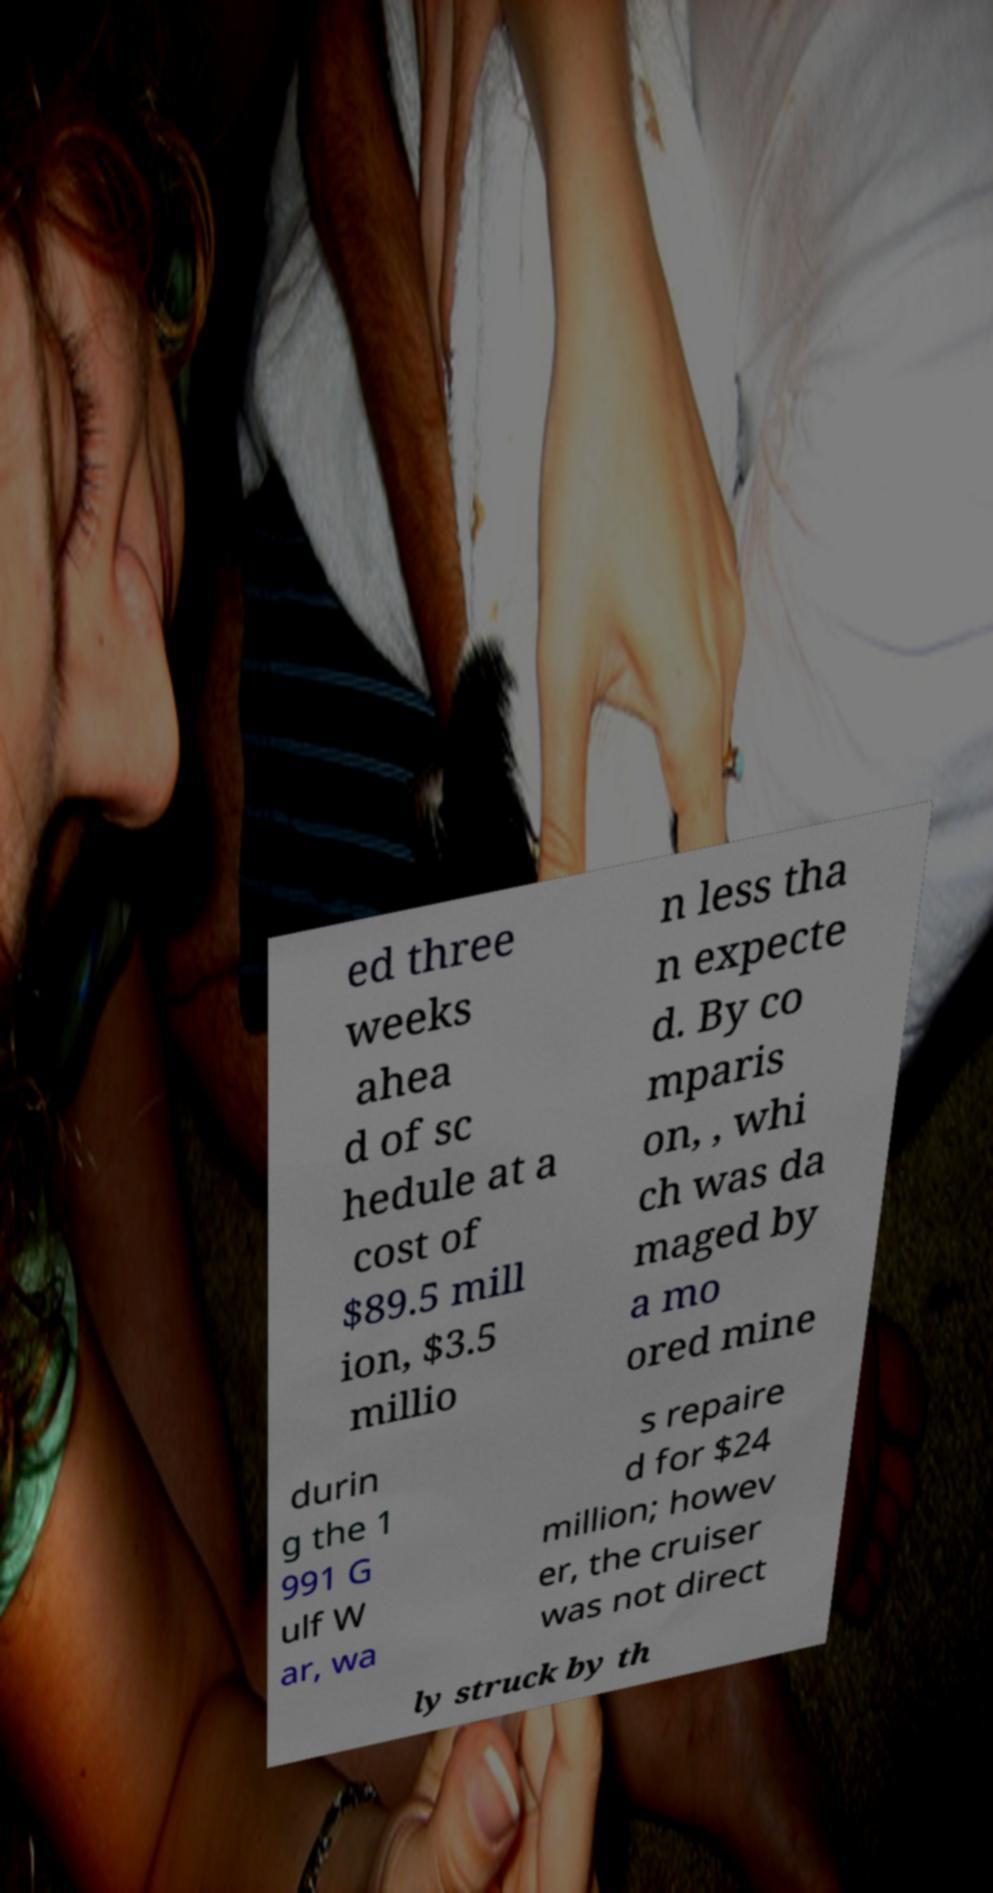Please read and relay the text visible in this image. What does it say? ed three weeks ahea d of sc hedule at a cost of $89.5 mill ion, $3.5 millio n less tha n expecte d. By co mparis on, , whi ch was da maged by a mo ored mine durin g the 1 991 G ulf W ar, wa s repaire d for $24 million; howev er, the cruiser was not direct ly struck by th 